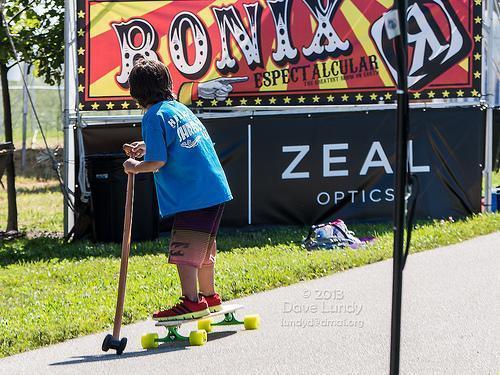How many boys are on skateboards?
Give a very brief answer. 1. 